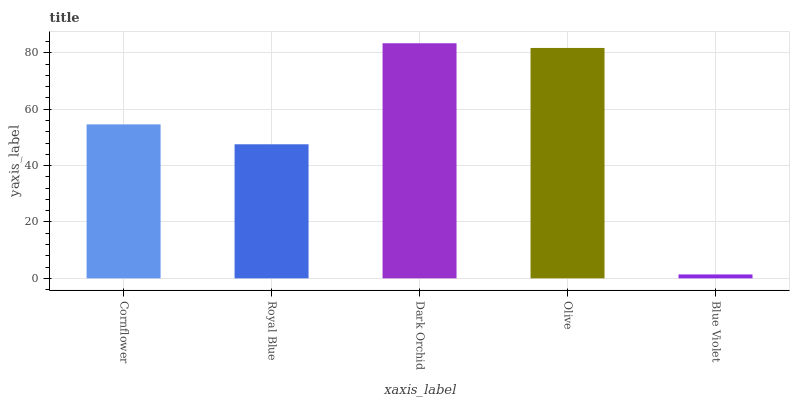Is Blue Violet the minimum?
Answer yes or no. Yes. Is Dark Orchid the maximum?
Answer yes or no. Yes. Is Royal Blue the minimum?
Answer yes or no. No. Is Royal Blue the maximum?
Answer yes or no. No. Is Cornflower greater than Royal Blue?
Answer yes or no. Yes. Is Royal Blue less than Cornflower?
Answer yes or no. Yes. Is Royal Blue greater than Cornflower?
Answer yes or no. No. Is Cornflower less than Royal Blue?
Answer yes or no. No. Is Cornflower the high median?
Answer yes or no. Yes. Is Cornflower the low median?
Answer yes or no. Yes. Is Royal Blue the high median?
Answer yes or no. No. Is Dark Orchid the low median?
Answer yes or no. No. 